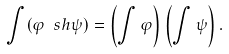<formula> <loc_0><loc_0><loc_500><loc_500>\int ( \varphi \ s h \psi ) = \left ( \int \varphi \right ) \left ( \int \psi \right ) .</formula> 